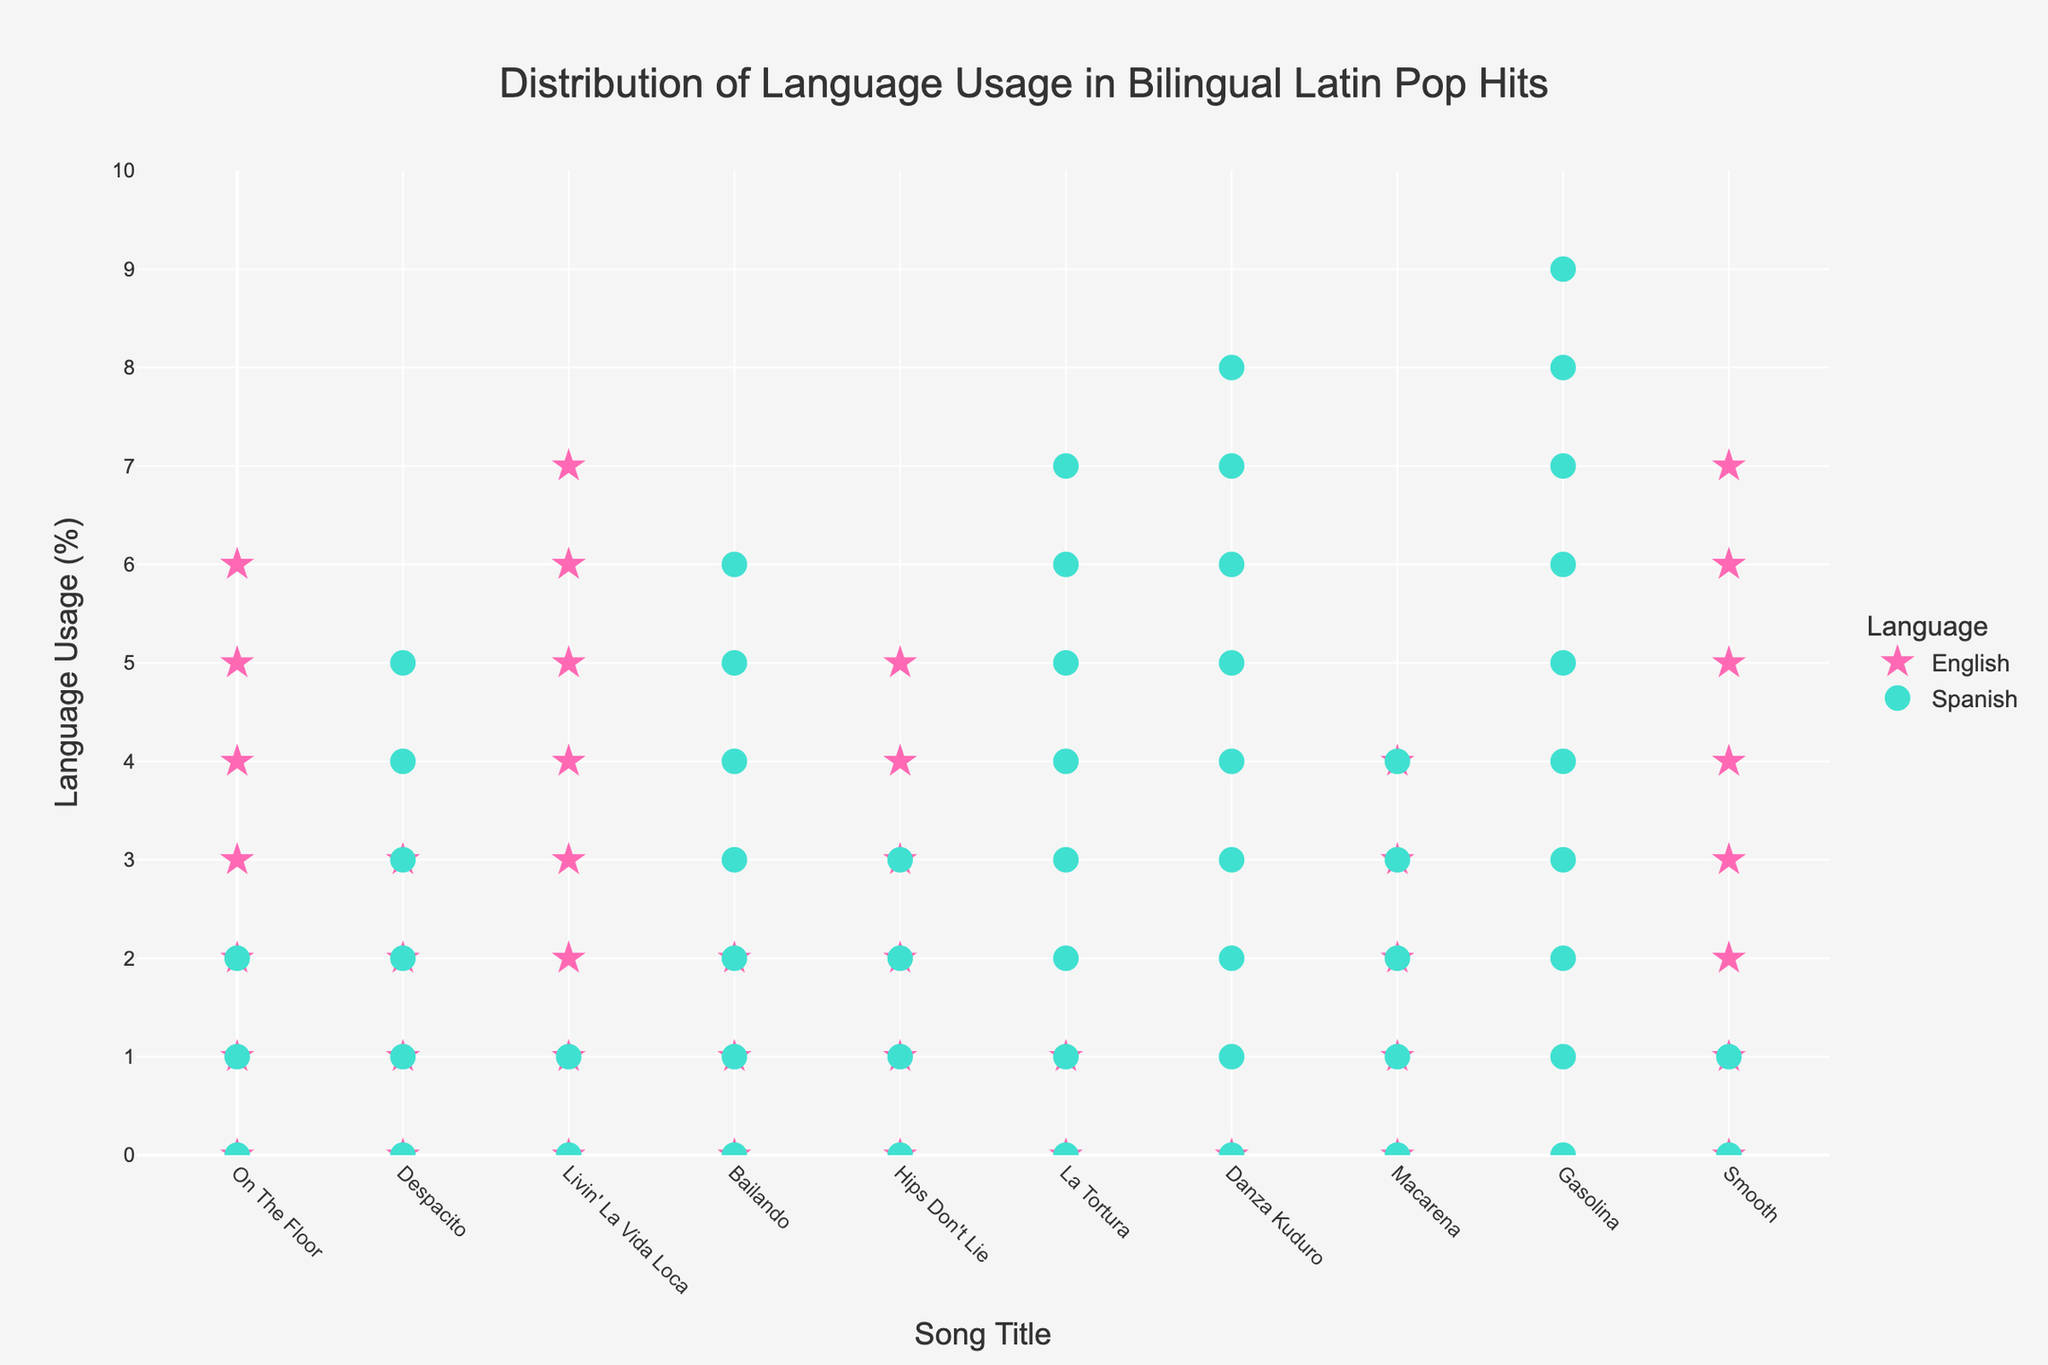What's the title of the figure? The title of the figure is usually found at the top and in this case, it is mentioned in the customization of the layout.
Answer: Distribution of Language Usage in Bilingual Latin Pop Hits How many songs have a higher percentage of English than Spanish? Count the songs where the number of English icons is more than the number of Spanish icons.
Answer: 6 Which song has the highest percentage of Spanish lyrics? Identify the song with the maximum number of Spanish icons.
Answer: Gasolina What's the percentage of English for "Hips Don't Lie"? Look at the number of English icons for "Hips Don't Lie" and multiply by 10.
Answer: 60% How many songs have an equal percentage of English and Spanish? Identify the song(s) with an equal number of English and Spanish icons.
Answer: 1 (Macarena) Which song has the largest difference in language usage percentages? Find the song with the greatest difference between the number of English and Spanish icons.
Answer: Gasolina What is the average percentage of Spanish lyrics across all songs? Sum the percentages of Spanish for all songs and divide by the number of songs (10).
Answer: 56% Are there more songs with predominantly English lyrics or predominantly Spanish lyrics? Count the number of songs with predominantly English icons and those with predominantly Spanish icons and compare.
Answer: More Spanish How many songs have less than 50% English lyrics? Identify and count the songs where the number of English icons is less than the number of Spanish icons.
Answer: 4 Which songs have exactly 70% Spanish lyrics? Identify songs that have 7 Spanish icons.
Answer: Bailando 